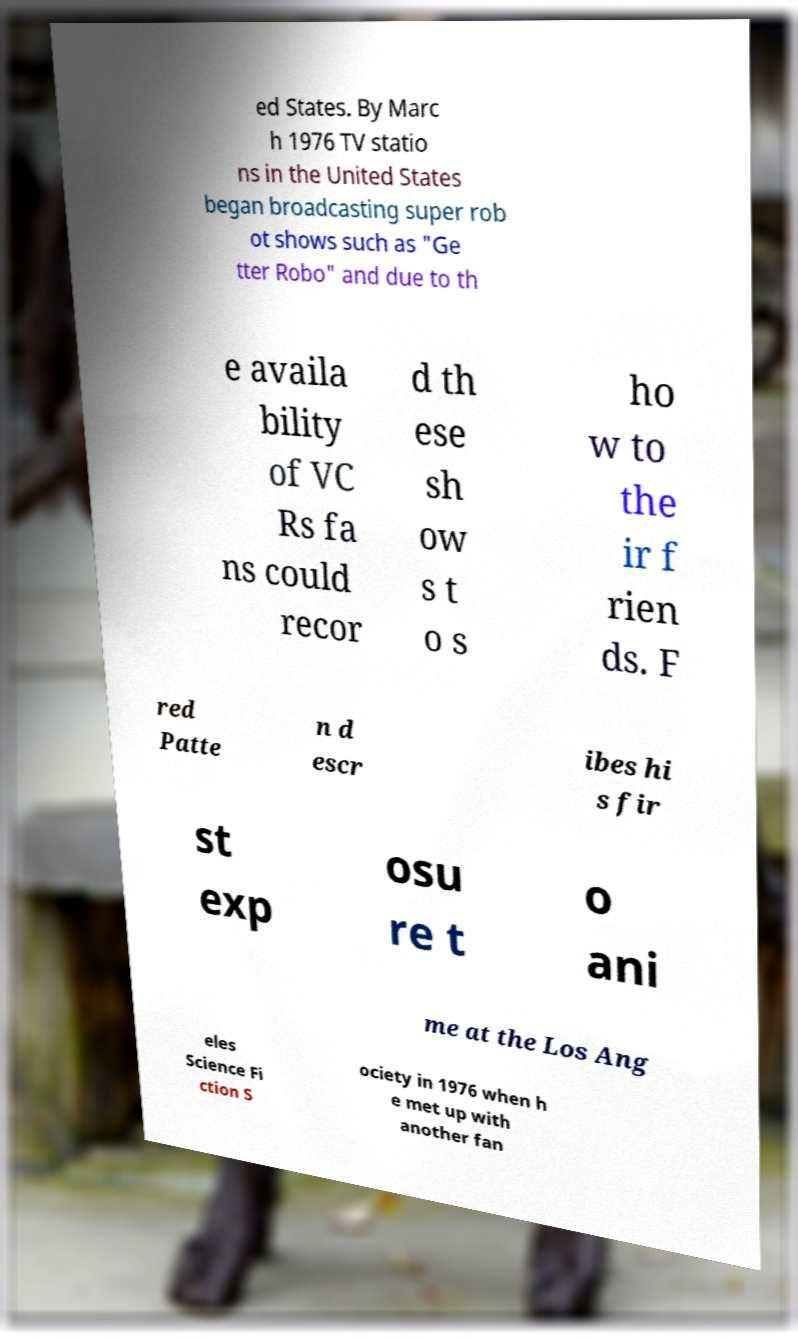I need the written content from this picture converted into text. Can you do that? ed States. By Marc h 1976 TV statio ns in the United States began broadcasting super rob ot shows such as "Ge tter Robo" and due to th e availa bility of VC Rs fa ns could recor d th ese sh ow s t o s ho w to the ir f rien ds. F red Patte n d escr ibes hi s fir st exp osu re t o ani me at the Los Ang eles Science Fi ction S ociety in 1976 when h e met up with another fan 